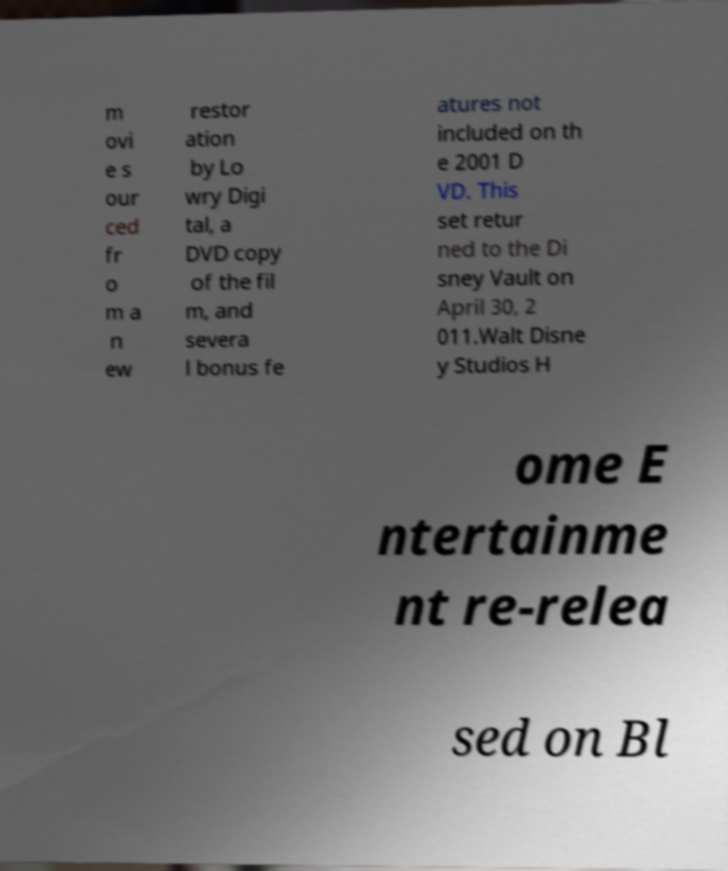Please read and relay the text visible in this image. What does it say? m ovi e s our ced fr o m a n ew restor ation by Lo wry Digi tal, a DVD copy of the fil m, and severa l bonus fe atures not included on th e 2001 D VD. This set retur ned to the Di sney Vault on April 30, 2 011.Walt Disne y Studios H ome E ntertainme nt re-relea sed on Bl 